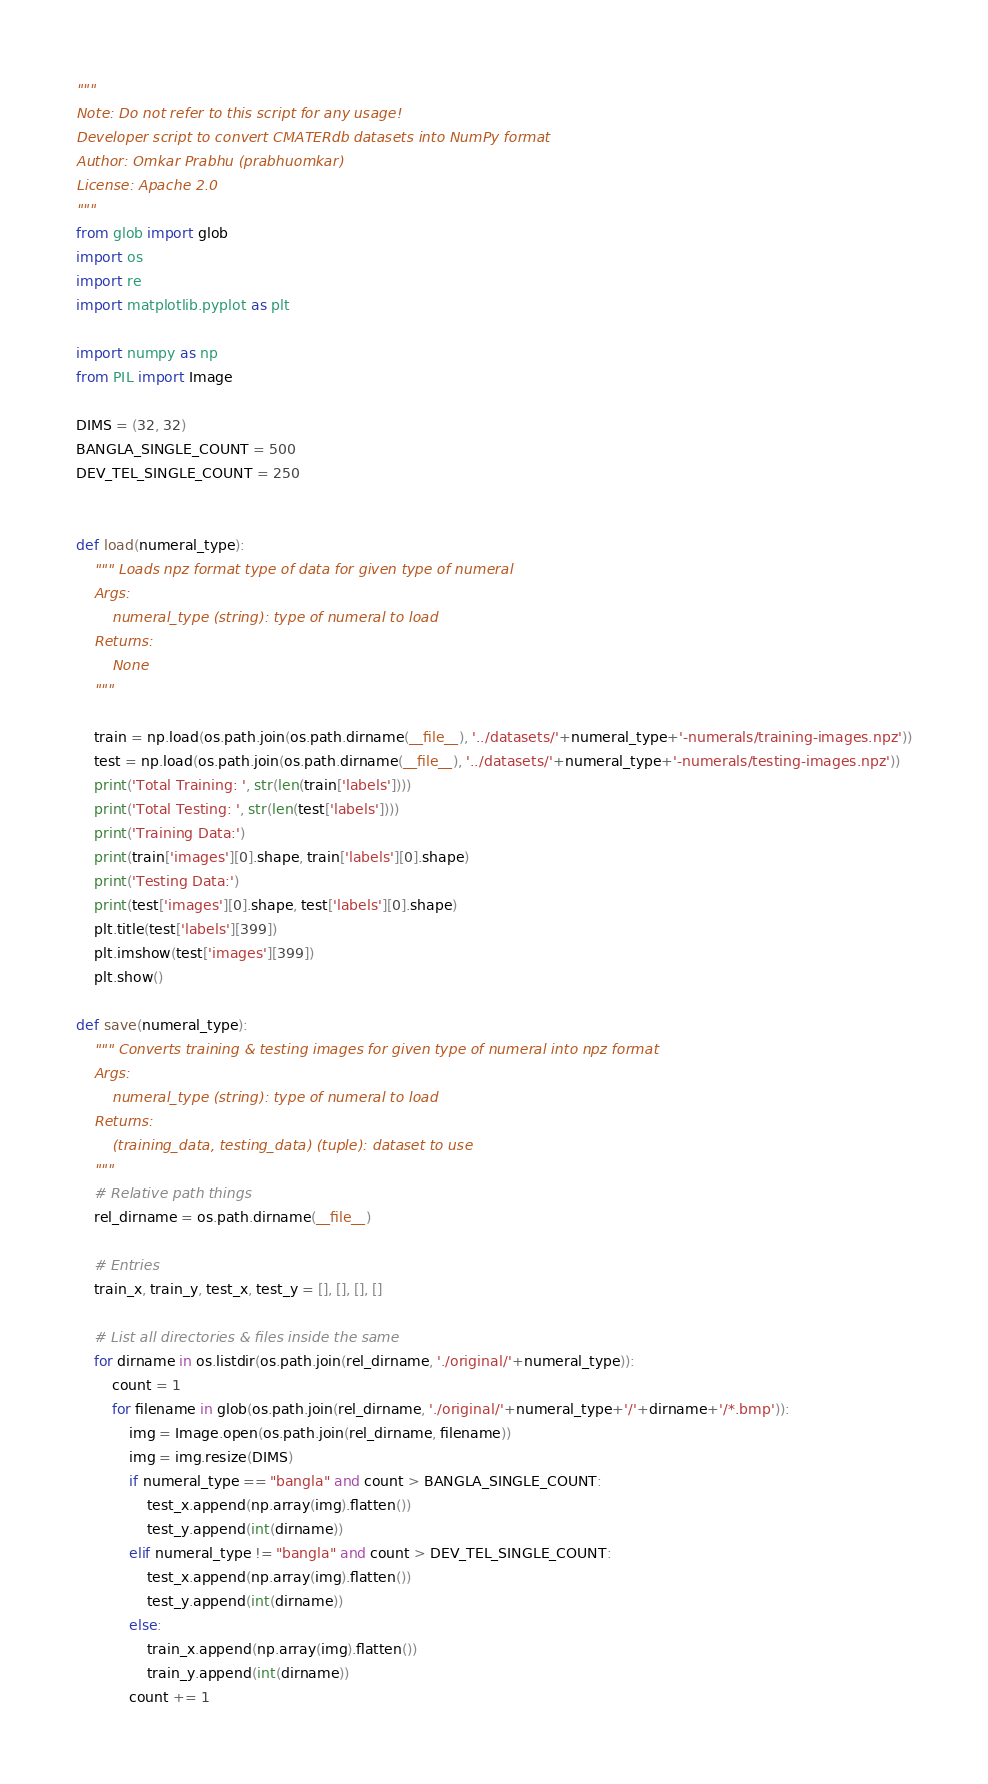Convert code to text. <code><loc_0><loc_0><loc_500><loc_500><_Python_>"""
Note: Do not refer to this script for any usage!
Developer script to convert CMATERdb datasets into NumPy format
Author: Omkar Prabhu (prabhuomkar)
License: Apache 2.0
"""
from glob import glob
import os
import re
import matplotlib.pyplot as plt

import numpy as np
from PIL import Image

DIMS = (32, 32)
BANGLA_SINGLE_COUNT = 500
DEV_TEL_SINGLE_COUNT = 250


def load(numeral_type):
    """ Loads npz format type of data for given type of numeral 
    Args:
        numeral_type (string): type of numeral to load
    Returns:
        None
    """

    train = np.load(os.path.join(os.path.dirname(__file__), '../datasets/'+numeral_type+'-numerals/training-images.npz'))
    test = np.load(os.path.join(os.path.dirname(__file__), '../datasets/'+numeral_type+'-numerals/testing-images.npz'))
    print('Total Training: ', str(len(train['labels'])))
    print('Total Testing: ', str(len(test['labels'])))
    print('Training Data:')
    print(train['images'][0].shape, train['labels'][0].shape)
    print('Testing Data:')
    print(test['images'][0].shape, test['labels'][0].shape)
    plt.title(test['labels'][399])
    plt.imshow(test['images'][399])
    plt.show()

def save(numeral_type):
    """ Converts training & testing images for given type of numeral into npz format
    Args:
		numeral_type (string): type of numeral to load
	Returns:
		(training_data, testing_data) (tuple): dataset to use
    """
    # Relative path things
    rel_dirname = os.path.dirname(__file__)

    # Entries
    train_x, train_y, test_x, test_y = [], [], [], []

    # List all directories & files inside the same
    for dirname in os.listdir(os.path.join(rel_dirname, './original/'+numeral_type)):
        count = 1
        for filename in glob(os.path.join(rel_dirname, './original/'+numeral_type+'/'+dirname+'/*.bmp')):
            img = Image.open(os.path.join(rel_dirname, filename))
            img = img.resize(DIMS)
            if numeral_type == "bangla" and count > BANGLA_SINGLE_COUNT:
                test_x.append(np.array(img).flatten())
                test_y.append(int(dirname))
            elif numeral_type != "bangla" and count > DEV_TEL_SINGLE_COUNT:
                test_x.append(np.array(img).flatten())
                test_y.append(int(dirname))
            else:
                train_x.append(np.array(img).flatten())
                train_y.append(int(dirname))
            count += 1
</code> 